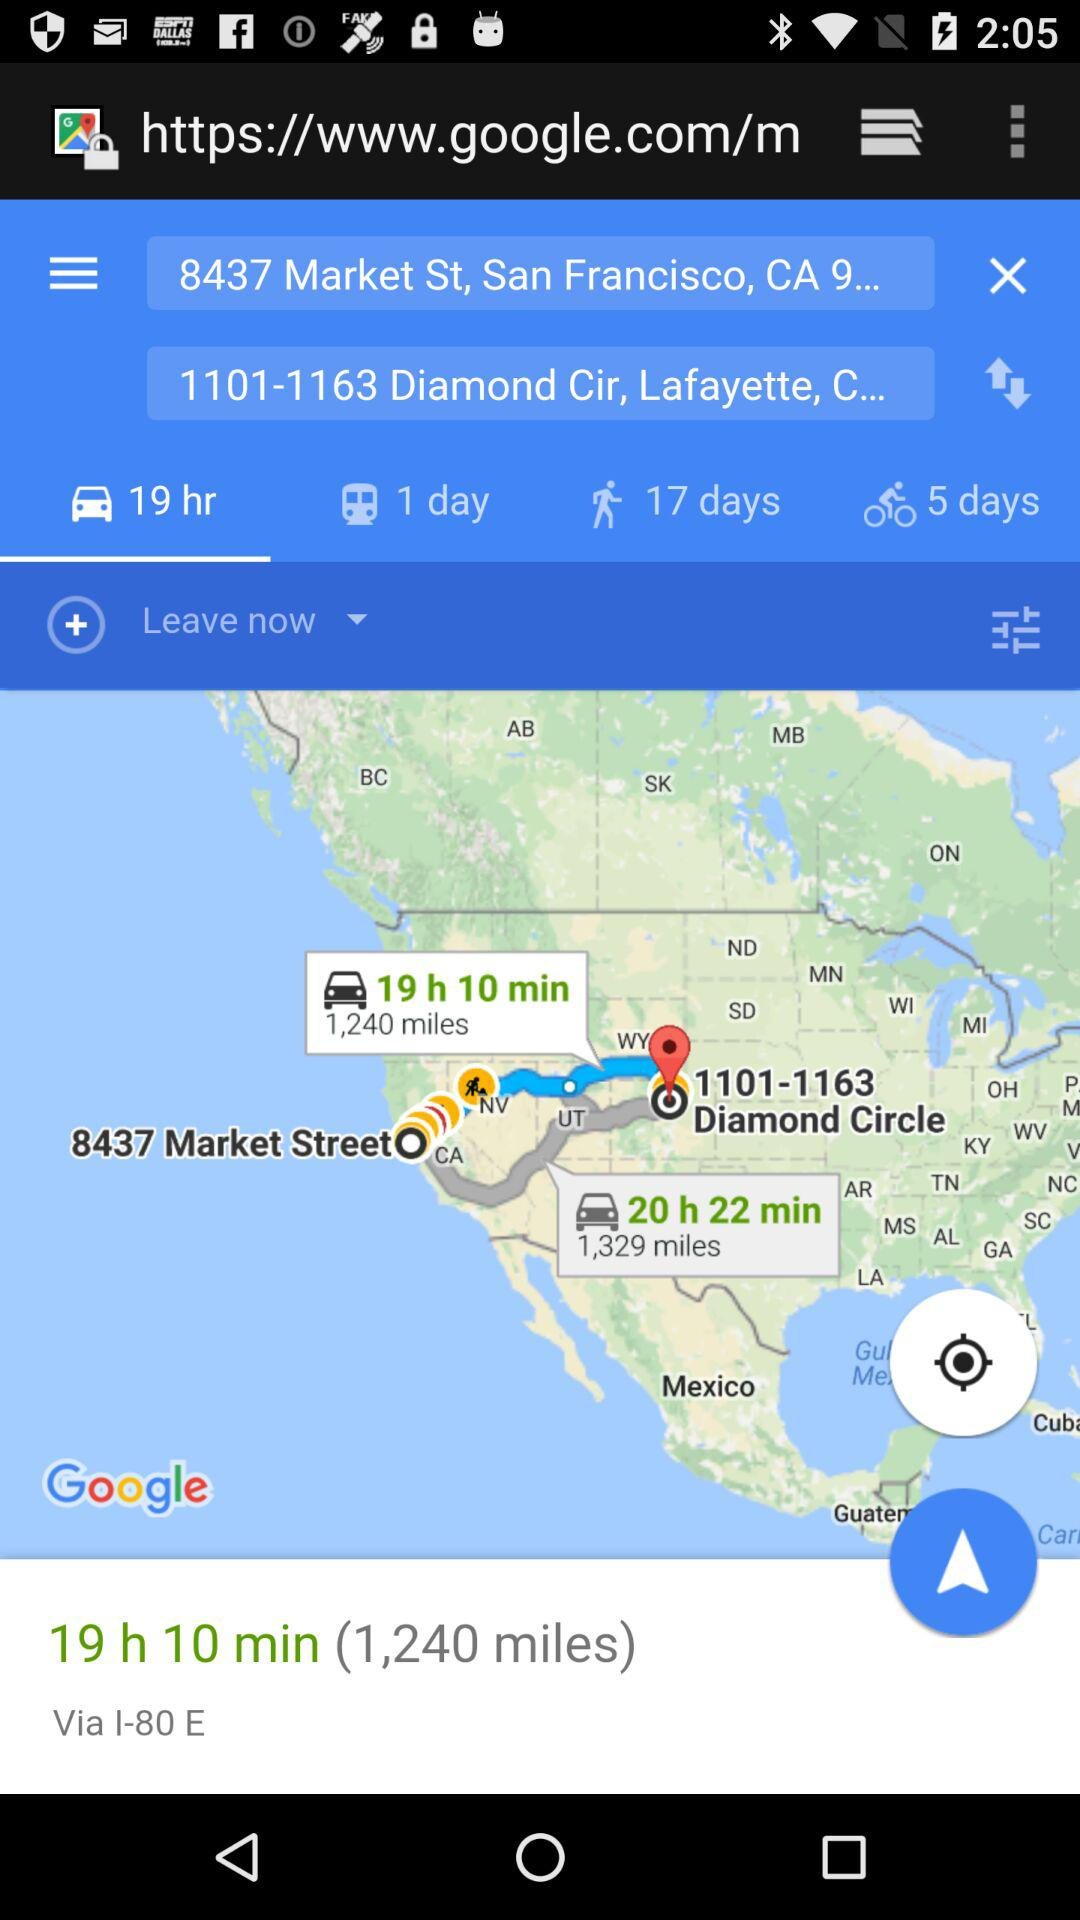What is duration left?
When the provided information is insufficient, respond with <no answer>. <no answer> 